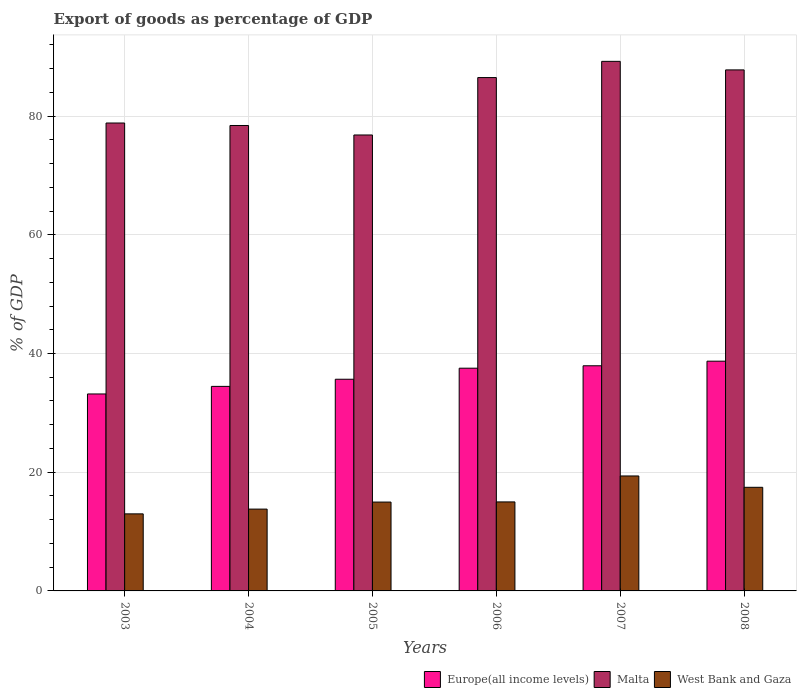How many different coloured bars are there?
Your answer should be compact. 3. Are the number of bars on each tick of the X-axis equal?
Offer a very short reply. Yes. How many bars are there on the 4th tick from the left?
Your response must be concise. 3. What is the label of the 6th group of bars from the left?
Give a very brief answer. 2008. In how many cases, is the number of bars for a given year not equal to the number of legend labels?
Your answer should be compact. 0. What is the export of goods as percentage of GDP in West Bank and Gaza in 2004?
Provide a succinct answer. 13.79. Across all years, what is the maximum export of goods as percentage of GDP in Europe(all income levels)?
Your answer should be very brief. 38.71. Across all years, what is the minimum export of goods as percentage of GDP in West Bank and Gaza?
Your answer should be very brief. 12.98. What is the total export of goods as percentage of GDP in Europe(all income levels) in the graph?
Give a very brief answer. 217.47. What is the difference between the export of goods as percentage of GDP in West Bank and Gaza in 2003 and that in 2007?
Provide a succinct answer. -6.39. What is the difference between the export of goods as percentage of GDP in Europe(all income levels) in 2008 and the export of goods as percentage of GDP in West Bank and Gaza in 2006?
Your answer should be very brief. 23.71. What is the average export of goods as percentage of GDP in Europe(all income levels) per year?
Provide a succinct answer. 36.24. In the year 2006, what is the difference between the export of goods as percentage of GDP in Europe(all income levels) and export of goods as percentage of GDP in Malta?
Provide a succinct answer. -48.96. What is the ratio of the export of goods as percentage of GDP in Europe(all income levels) in 2004 to that in 2006?
Offer a terse response. 0.92. Is the export of goods as percentage of GDP in Malta in 2004 less than that in 2007?
Offer a terse response. Yes. What is the difference between the highest and the second highest export of goods as percentage of GDP in Europe(all income levels)?
Keep it short and to the point. 0.77. What is the difference between the highest and the lowest export of goods as percentage of GDP in West Bank and Gaza?
Your answer should be very brief. 6.39. Is the sum of the export of goods as percentage of GDP in West Bank and Gaza in 2006 and 2008 greater than the maximum export of goods as percentage of GDP in Europe(all income levels) across all years?
Your answer should be very brief. No. What does the 1st bar from the left in 2008 represents?
Your answer should be compact. Europe(all income levels). What does the 1st bar from the right in 2006 represents?
Offer a very short reply. West Bank and Gaza. Is it the case that in every year, the sum of the export of goods as percentage of GDP in Europe(all income levels) and export of goods as percentage of GDP in West Bank and Gaza is greater than the export of goods as percentage of GDP in Malta?
Your response must be concise. No. Are all the bars in the graph horizontal?
Offer a very short reply. No. Are the values on the major ticks of Y-axis written in scientific E-notation?
Ensure brevity in your answer.  No. Does the graph contain any zero values?
Offer a terse response. No. Does the graph contain grids?
Your answer should be compact. Yes. Where does the legend appear in the graph?
Ensure brevity in your answer.  Bottom right. How are the legend labels stacked?
Your response must be concise. Horizontal. What is the title of the graph?
Ensure brevity in your answer.  Export of goods as percentage of GDP. Does "Brazil" appear as one of the legend labels in the graph?
Offer a terse response. No. What is the label or title of the X-axis?
Offer a very short reply. Years. What is the label or title of the Y-axis?
Give a very brief answer. % of GDP. What is the % of GDP of Europe(all income levels) in 2003?
Provide a succinct answer. 33.18. What is the % of GDP of Malta in 2003?
Give a very brief answer. 78.83. What is the % of GDP in West Bank and Gaza in 2003?
Ensure brevity in your answer.  12.98. What is the % of GDP in Europe(all income levels) in 2004?
Give a very brief answer. 34.46. What is the % of GDP of Malta in 2004?
Provide a short and direct response. 78.41. What is the % of GDP of West Bank and Gaza in 2004?
Your answer should be very brief. 13.79. What is the % of GDP in Europe(all income levels) in 2005?
Offer a terse response. 35.66. What is the % of GDP in Malta in 2005?
Provide a succinct answer. 76.81. What is the % of GDP in West Bank and Gaza in 2005?
Offer a terse response. 14.97. What is the % of GDP of Europe(all income levels) in 2006?
Offer a terse response. 37.52. What is the % of GDP of Malta in 2006?
Your response must be concise. 86.49. What is the % of GDP in West Bank and Gaza in 2006?
Keep it short and to the point. 15. What is the % of GDP in Europe(all income levels) in 2007?
Make the answer very short. 37.93. What is the % of GDP of Malta in 2007?
Provide a short and direct response. 89.22. What is the % of GDP in West Bank and Gaza in 2007?
Give a very brief answer. 19.37. What is the % of GDP in Europe(all income levels) in 2008?
Provide a succinct answer. 38.71. What is the % of GDP in Malta in 2008?
Provide a succinct answer. 87.78. What is the % of GDP of West Bank and Gaza in 2008?
Provide a succinct answer. 17.46. Across all years, what is the maximum % of GDP of Europe(all income levels)?
Your answer should be very brief. 38.71. Across all years, what is the maximum % of GDP in Malta?
Keep it short and to the point. 89.22. Across all years, what is the maximum % of GDP of West Bank and Gaza?
Keep it short and to the point. 19.37. Across all years, what is the minimum % of GDP in Europe(all income levels)?
Offer a terse response. 33.18. Across all years, what is the minimum % of GDP of Malta?
Provide a succinct answer. 76.81. Across all years, what is the minimum % of GDP in West Bank and Gaza?
Your answer should be compact. 12.98. What is the total % of GDP in Europe(all income levels) in the graph?
Provide a short and direct response. 217.47. What is the total % of GDP in Malta in the graph?
Keep it short and to the point. 497.54. What is the total % of GDP of West Bank and Gaza in the graph?
Keep it short and to the point. 93.56. What is the difference between the % of GDP in Europe(all income levels) in 2003 and that in 2004?
Keep it short and to the point. -1.28. What is the difference between the % of GDP in Malta in 2003 and that in 2004?
Offer a terse response. 0.42. What is the difference between the % of GDP of West Bank and Gaza in 2003 and that in 2004?
Your response must be concise. -0.8. What is the difference between the % of GDP in Europe(all income levels) in 2003 and that in 2005?
Offer a very short reply. -2.48. What is the difference between the % of GDP of Malta in 2003 and that in 2005?
Give a very brief answer. 2.02. What is the difference between the % of GDP in West Bank and Gaza in 2003 and that in 2005?
Make the answer very short. -1.99. What is the difference between the % of GDP in Europe(all income levels) in 2003 and that in 2006?
Your answer should be very brief. -4.34. What is the difference between the % of GDP of Malta in 2003 and that in 2006?
Your answer should be compact. -7.65. What is the difference between the % of GDP of West Bank and Gaza in 2003 and that in 2006?
Make the answer very short. -2.01. What is the difference between the % of GDP of Europe(all income levels) in 2003 and that in 2007?
Offer a terse response. -4.75. What is the difference between the % of GDP of Malta in 2003 and that in 2007?
Keep it short and to the point. -10.39. What is the difference between the % of GDP in West Bank and Gaza in 2003 and that in 2007?
Offer a terse response. -6.39. What is the difference between the % of GDP of Europe(all income levels) in 2003 and that in 2008?
Provide a succinct answer. -5.52. What is the difference between the % of GDP of Malta in 2003 and that in 2008?
Make the answer very short. -8.95. What is the difference between the % of GDP in West Bank and Gaza in 2003 and that in 2008?
Offer a terse response. -4.48. What is the difference between the % of GDP in Europe(all income levels) in 2004 and that in 2005?
Provide a short and direct response. -1.2. What is the difference between the % of GDP of Malta in 2004 and that in 2005?
Make the answer very short. 1.6. What is the difference between the % of GDP in West Bank and Gaza in 2004 and that in 2005?
Ensure brevity in your answer.  -1.18. What is the difference between the % of GDP in Europe(all income levels) in 2004 and that in 2006?
Your answer should be compact. -3.07. What is the difference between the % of GDP in Malta in 2004 and that in 2006?
Your response must be concise. -8.07. What is the difference between the % of GDP of West Bank and Gaza in 2004 and that in 2006?
Make the answer very short. -1.21. What is the difference between the % of GDP of Europe(all income levels) in 2004 and that in 2007?
Ensure brevity in your answer.  -3.47. What is the difference between the % of GDP in Malta in 2004 and that in 2007?
Offer a terse response. -10.81. What is the difference between the % of GDP of West Bank and Gaza in 2004 and that in 2007?
Your answer should be compact. -5.58. What is the difference between the % of GDP in Europe(all income levels) in 2004 and that in 2008?
Ensure brevity in your answer.  -4.25. What is the difference between the % of GDP in Malta in 2004 and that in 2008?
Your answer should be very brief. -9.37. What is the difference between the % of GDP in West Bank and Gaza in 2004 and that in 2008?
Give a very brief answer. -3.67. What is the difference between the % of GDP in Europe(all income levels) in 2005 and that in 2006?
Your response must be concise. -1.86. What is the difference between the % of GDP of Malta in 2005 and that in 2006?
Offer a terse response. -9.67. What is the difference between the % of GDP of West Bank and Gaza in 2005 and that in 2006?
Offer a terse response. -0.03. What is the difference between the % of GDP in Europe(all income levels) in 2005 and that in 2007?
Your answer should be very brief. -2.27. What is the difference between the % of GDP in Malta in 2005 and that in 2007?
Ensure brevity in your answer.  -12.4. What is the difference between the % of GDP of West Bank and Gaza in 2005 and that in 2007?
Give a very brief answer. -4.4. What is the difference between the % of GDP of Europe(all income levels) in 2005 and that in 2008?
Offer a very short reply. -3.04. What is the difference between the % of GDP of Malta in 2005 and that in 2008?
Ensure brevity in your answer.  -10.96. What is the difference between the % of GDP in West Bank and Gaza in 2005 and that in 2008?
Provide a succinct answer. -2.49. What is the difference between the % of GDP of Europe(all income levels) in 2006 and that in 2007?
Ensure brevity in your answer.  -0.41. What is the difference between the % of GDP in Malta in 2006 and that in 2007?
Your answer should be very brief. -2.73. What is the difference between the % of GDP of West Bank and Gaza in 2006 and that in 2007?
Your answer should be very brief. -4.37. What is the difference between the % of GDP in Europe(all income levels) in 2006 and that in 2008?
Your response must be concise. -1.18. What is the difference between the % of GDP of Malta in 2006 and that in 2008?
Keep it short and to the point. -1.29. What is the difference between the % of GDP of West Bank and Gaza in 2006 and that in 2008?
Offer a very short reply. -2.46. What is the difference between the % of GDP of Europe(all income levels) in 2007 and that in 2008?
Provide a succinct answer. -0.77. What is the difference between the % of GDP in Malta in 2007 and that in 2008?
Your answer should be compact. 1.44. What is the difference between the % of GDP of West Bank and Gaza in 2007 and that in 2008?
Your response must be concise. 1.91. What is the difference between the % of GDP of Europe(all income levels) in 2003 and the % of GDP of Malta in 2004?
Ensure brevity in your answer.  -45.23. What is the difference between the % of GDP of Europe(all income levels) in 2003 and the % of GDP of West Bank and Gaza in 2004?
Offer a very short reply. 19.4. What is the difference between the % of GDP of Malta in 2003 and the % of GDP of West Bank and Gaza in 2004?
Your response must be concise. 65.05. What is the difference between the % of GDP of Europe(all income levels) in 2003 and the % of GDP of Malta in 2005?
Provide a short and direct response. -43.63. What is the difference between the % of GDP in Europe(all income levels) in 2003 and the % of GDP in West Bank and Gaza in 2005?
Your answer should be compact. 18.21. What is the difference between the % of GDP of Malta in 2003 and the % of GDP of West Bank and Gaza in 2005?
Offer a terse response. 63.86. What is the difference between the % of GDP in Europe(all income levels) in 2003 and the % of GDP in Malta in 2006?
Ensure brevity in your answer.  -53.3. What is the difference between the % of GDP in Europe(all income levels) in 2003 and the % of GDP in West Bank and Gaza in 2006?
Offer a terse response. 18.19. What is the difference between the % of GDP in Malta in 2003 and the % of GDP in West Bank and Gaza in 2006?
Offer a terse response. 63.84. What is the difference between the % of GDP in Europe(all income levels) in 2003 and the % of GDP in Malta in 2007?
Make the answer very short. -56.04. What is the difference between the % of GDP of Europe(all income levels) in 2003 and the % of GDP of West Bank and Gaza in 2007?
Provide a succinct answer. 13.82. What is the difference between the % of GDP in Malta in 2003 and the % of GDP in West Bank and Gaza in 2007?
Your answer should be very brief. 59.46. What is the difference between the % of GDP in Europe(all income levels) in 2003 and the % of GDP in Malta in 2008?
Provide a succinct answer. -54.6. What is the difference between the % of GDP of Europe(all income levels) in 2003 and the % of GDP of West Bank and Gaza in 2008?
Your answer should be compact. 15.73. What is the difference between the % of GDP in Malta in 2003 and the % of GDP in West Bank and Gaza in 2008?
Provide a succinct answer. 61.37. What is the difference between the % of GDP in Europe(all income levels) in 2004 and the % of GDP in Malta in 2005?
Offer a very short reply. -42.36. What is the difference between the % of GDP in Europe(all income levels) in 2004 and the % of GDP in West Bank and Gaza in 2005?
Give a very brief answer. 19.49. What is the difference between the % of GDP in Malta in 2004 and the % of GDP in West Bank and Gaza in 2005?
Your answer should be very brief. 63.44. What is the difference between the % of GDP in Europe(all income levels) in 2004 and the % of GDP in Malta in 2006?
Provide a short and direct response. -52.03. What is the difference between the % of GDP in Europe(all income levels) in 2004 and the % of GDP in West Bank and Gaza in 2006?
Offer a very short reply. 19.46. What is the difference between the % of GDP in Malta in 2004 and the % of GDP in West Bank and Gaza in 2006?
Make the answer very short. 63.42. What is the difference between the % of GDP in Europe(all income levels) in 2004 and the % of GDP in Malta in 2007?
Your answer should be very brief. -54.76. What is the difference between the % of GDP of Europe(all income levels) in 2004 and the % of GDP of West Bank and Gaza in 2007?
Your answer should be compact. 15.09. What is the difference between the % of GDP in Malta in 2004 and the % of GDP in West Bank and Gaza in 2007?
Keep it short and to the point. 59.05. What is the difference between the % of GDP in Europe(all income levels) in 2004 and the % of GDP in Malta in 2008?
Your response must be concise. -53.32. What is the difference between the % of GDP in Europe(all income levels) in 2004 and the % of GDP in West Bank and Gaza in 2008?
Ensure brevity in your answer.  17. What is the difference between the % of GDP in Malta in 2004 and the % of GDP in West Bank and Gaza in 2008?
Keep it short and to the point. 60.96. What is the difference between the % of GDP of Europe(all income levels) in 2005 and the % of GDP of Malta in 2006?
Your response must be concise. -50.82. What is the difference between the % of GDP of Europe(all income levels) in 2005 and the % of GDP of West Bank and Gaza in 2006?
Make the answer very short. 20.67. What is the difference between the % of GDP of Malta in 2005 and the % of GDP of West Bank and Gaza in 2006?
Ensure brevity in your answer.  61.82. What is the difference between the % of GDP of Europe(all income levels) in 2005 and the % of GDP of Malta in 2007?
Your answer should be very brief. -53.56. What is the difference between the % of GDP of Europe(all income levels) in 2005 and the % of GDP of West Bank and Gaza in 2007?
Ensure brevity in your answer.  16.3. What is the difference between the % of GDP of Malta in 2005 and the % of GDP of West Bank and Gaza in 2007?
Your response must be concise. 57.45. What is the difference between the % of GDP of Europe(all income levels) in 2005 and the % of GDP of Malta in 2008?
Your answer should be very brief. -52.12. What is the difference between the % of GDP of Europe(all income levels) in 2005 and the % of GDP of West Bank and Gaza in 2008?
Offer a terse response. 18.2. What is the difference between the % of GDP in Malta in 2005 and the % of GDP in West Bank and Gaza in 2008?
Your answer should be compact. 59.36. What is the difference between the % of GDP of Europe(all income levels) in 2006 and the % of GDP of Malta in 2007?
Keep it short and to the point. -51.7. What is the difference between the % of GDP in Europe(all income levels) in 2006 and the % of GDP in West Bank and Gaza in 2007?
Give a very brief answer. 18.16. What is the difference between the % of GDP of Malta in 2006 and the % of GDP of West Bank and Gaza in 2007?
Provide a succinct answer. 67.12. What is the difference between the % of GDP of Europe(all income levels) in 2006 and the % of GDP of Malta in 2008?
Your response must be concise. -50.25. What is the difference between the % of GDP in Europe(all income levels) in 2006 and the % of GDP in West Bank and Gaza in 2008?
Keep it short and to the point. 20.07. What is the difference between the % of GDP in Malta in 2006 and the % of GDP in West Bank and Gaza in 2008?
Keep it short and to the point. 69.03. What is the difference between the % of GDP in Europe(all income levels) in 2007 and the % of GDP in Malta in 2008?
Give a very brief answer. -49.85. What is the difference between the % of GDP of Europe(all income levels) in 2007 and the % of GDP of West Bank and Gaza in 2008?
Make the answer very short. 20.47. What is the difference between the % of GDP in Malta in 2007 and the % of GDP in West Bank and Gaza in 2008?
Keep it short and to the point. 71.76. What is the average % of GDP of Europe(all income levels) per year?
Your answer should be very brief. 36.24. What is the average % of GDP in Malta per year?
Ensure brevity in your answer.  82.92. What is the average % of GDP in West Bank and Gaza per year?
Your answer should be very brief. 15.59. In the year 2003, what is the difference between the % of GDP in Europe(all income levels) and % of GDP in Malta?
Offer a terse response. -45.65. In the year 2003, what is the difference between the % of GDP of Europe(all income levels) and % of GDP of West Bank and Gaza?
Your answer should be very brief. 20.2. In the year 2003, what is the difference between the % of GDP of Malta and % of GDP of West Bank and Gaza?
Make the answer very short. 65.85. In the year 2004, what is the difference between the % of GDP in Europe(all income levels) and % of GDP in Malta?
Give a very brief answer. -43.95. In the year 2004, what is the difference between the % of GDP of Europe(all income levels) and % of GDP of West Bank and Gaza?
Give a very brief answer. 20.67. In the year 2004, what is the difference between the % of GDP of Malta and % of GDP of West Bank and Gaza?
Ensure brevity in your answer.  64.63. In the year 2005, what is the difference between the % of GDP in Europe(all income levels) and % of GDP in Malta?
Provide a short and direct response. -41.15. In the year 2005, what is the difference between the % of GDP in Europe(all income levels) and % of GDP in West Bank and Gaza?
Provide a succinct answer. 20.69. In the year 2005, what is the difference between the % of GDP of Malta and % of GDP of West Bank and Gaza?
Give a very brief answer. 61.84. In the year 2006, what is the difference between the % of GDP in Europe(all income levels) and % of GDP in Malta?
Give a very brief answer. -48.96. In the year 2006, what is the difference between the % of GDP of Europe(all income levels) and % of GDP of West Bank and Gaza?
Keep it short and to the point. 22.53. In the year 2006, what is the difference between the % of GDP in Malta and % of GDP in West Bank and Gaza?
Offer a terse response. 71.49. In the year 2007, what is the difference between the % of GDP of Europe(all income levels) and % of GDP of Malta?
Offer a terse response. -51.29. In the year 2007, what is the difference between the % of GDP of Europe(all income levels) and % of GDP of West Bank and Gaza?
Give a very brief answer. 18.56. In the year 2007, what is the difference between the % of GDP in Malta and % of GDP in West Bank and Gaza?
Offer a very short reply. 69.85. In the year 2008, what is the difference between the % of GDP in Europe(all income levels) and % of GDP in Malta?
Ensure brevity in your answer.  -49.07. In the year 2008, what is the difference between the % of GDP in Europe(all income levels) and % of GDP in West Bank and Gaza?
Give a very brief answer. 21.25. In the year 2008, what is the difference between the % of GDP in Malta and % of GDP in West Bank and Gaza?
Provide a succinct answer. 70.32. What is the ratio of the % of GDP in Malta in 2003 to that in 2004?
Give a very brief answer. 1.01. What is the ratio of the % of GDP of West Bank and Gaza in 2003 to that in 2004?
Keep it short and to the point. 0.94. What is the ratio of the % of GDP of Europe(all income levels) in 2003 to that in 2005?
Keep it short and to the point. 0.93. What is the ratio of the % of GDP of Malta in 2003 to that in 2005?
Keep it short and to the point. 1.03. What is the ratio of the % of GDP of West Bank and Gaza in 2003 to that in 2005?
Give a very brief answer. 0.87. What is the ratio of the % of GDP in Europe(all income levels) in 2003 to that in 2006?
Make the answer very short. 0.88. What is the ratio of the % of GDP of Malta in 2003 to that in 2006?
Provide a succinct answer. 0.91. What is the ratio of the % of GDP in West Bank and Gaza in 2003 to that in 2006?
Offer a very short reply. 0.87. What is the ratio of the % of GDP in Europe(all income levels) in 2003 to that in 2007?
Your answer should be very brief. 0.87. What is the ratio of the % of GDP of Malta in 2003 to that in 2007?
Provide a succinct answer. 0.88. What is the ratio of the % of GDP of West Bank and Gaza in 2003 to that in 2007?
Keep it short and to the point. 0.67. What is the ratio of the % of GDP in Europe(all income levels) in 2003 to that in 2008?
Ensure brevity in your answer.  0.86. What is the ratio of the % of GDP in Malta in 2003 to that in 2008?
Ensure brevity in your answer.  0.9. What is the ratio of the % of GDP in West Bank and Gaza in 2003 to that in 2008?
Provide a short and direct response. 0.74. What is the ratio of the % of GDP of Europe(all income levels) in 2004 to that in 2005?
Provide a succinct answer. 0.97. What is the ratio of the % of GDP in Malta in 2004 to that in 2005?
Ensure brevity in your answer.  1.02. What is the ratio of the % of GDP in West Bank and Gaza in 2004 to that in 2005?
Your answer should be compact. 0.92. What is the ratio of the % of GDP in Europe(all income levels) in 2004 to that in 2006?
Offer a very short reply. 0.92. What is the ratio of the % of GDP of Malta in 2004 to that in 2006?
Ensure brevity in your answer.  0.91. What is the ratio of the % of GDP of West Bank and Gaza in 2004 to that in 2006?
Keep it short and to the point. 0.92. What is the ratio of the % of GDP in Europe(all income levels) in 2004 to that in 2007?
Ensure brevity in your answer.  0.91. What is the ratio of the % of GDP of Malta in 2004 to that in 2007?
Provide a short and direct response. 0.88. What is the ratio of the % of GDP of West Bank and Gaza in 2004 to that in 2007?
Provide a short and direct response. 0.71. What is the ratio of the % of GDP of Europe(all income levels) in 2004 to that in 2008?
Your answer should be compact. 0.89. What is the ratio of the % of GDP in Malta in 2004 to that in 2008?
Give a very brief answer. 0.89. What is the ratio of the % of GDP in West Bank and Gaza in 2004 to that in 2008?
Provide a short and direct response. 0.79. What is the ratio of the % of GDP of Europe(all income levels) in 2005 to that in 2006?
Your answer should be compact. 0.95. What is the ratio of the % of GDP in Malta in 2005 to that in 2006?
Provide a succinct answer. 0.89. What is the ratio of the % of GDP in West Bank and Gaza in 2005 to that in 2006?
Provide a succinct answer. 1. What is the ratio of the % of GDP of Europe(all income levels) in 2005 to that in 2007?
Offer a terse response. 0.94. What is the ratio of the % of GDP in Malta in 2005 to that in 2007?
Offer a very short reply. 0.86. What is the ratio of the % of GDP in West Bank and Gaza in 2005 to that in 2007?
Your answer should be very brief. 0.77. What is the ratio of the % of GDP of Europe(all income levels) in 2005 to that in 2008?
Ensure brevity in your answer.  0.92. What is the ratio of the % of GDP of Malta in 2005 to that in 2008?
Provide a succinct answer. 0.88. What is the ratio of the % of GDP of West Bank and Gaza in 2005 to that in 2008?
Make the answer very short. 0.86. What is the ratio of the % of GDP of Europe(all income levels) in 2006 to that in 2007?
Keep it short and to the point. 0.99. What is the ratio of the % of GDP in Malta in 2006 to that in 2007?
Your response must be concise. 0.97. What is the ratio of the % of GDP of West Bank and Gaza in 2006 to that in 2007?
Give a very brief answer. 0.77. What is the ratio of the % of GDP in Europe(all income levels) in 2006 to that in 2008?
Your answer should be very brief. 0.97. What is the ratio of the % of GDP in Malta in 2006 to that in 2008?
Provide a succinct answer. 0.99. What is the ratio of the % of GDP in West Bank and Gaza in 2006 to that in 2008?
Your answer should be compact. 0.86. What is the ratio of the % of GDP in Malta in 2007 to that in 2008?
Give a very brief answer. 1.02. What is the ratio of the % of GDP of West Bank and Gaza in 2007 to that in 2008?
Offer a very short reply. 1.11. What is the difference between the highest and the second highest % of GDP in Europe(all income levels)?
Provide a short and direct response. 0.77. What is the difference between the highest and the second highest % of GDP of Malta?
Offer a very short reply. 1.44. What is the difference between the highest and the second highest % of GDP of West Bank and Gaza?
Ensure brevity in your answer.  1.91. What is the difference between the highest and the lowest % of GDP in Europe(all income levels)?
Your response must be concise. 5.52. What is the difference between the highest and the lowest % of GDP of Malta?
Your answer should be very brief. 12.4. What is the difference between the highest and the lowest % of GDP in West Bank and Gaza?
Give a very brief answer. 6.39. 